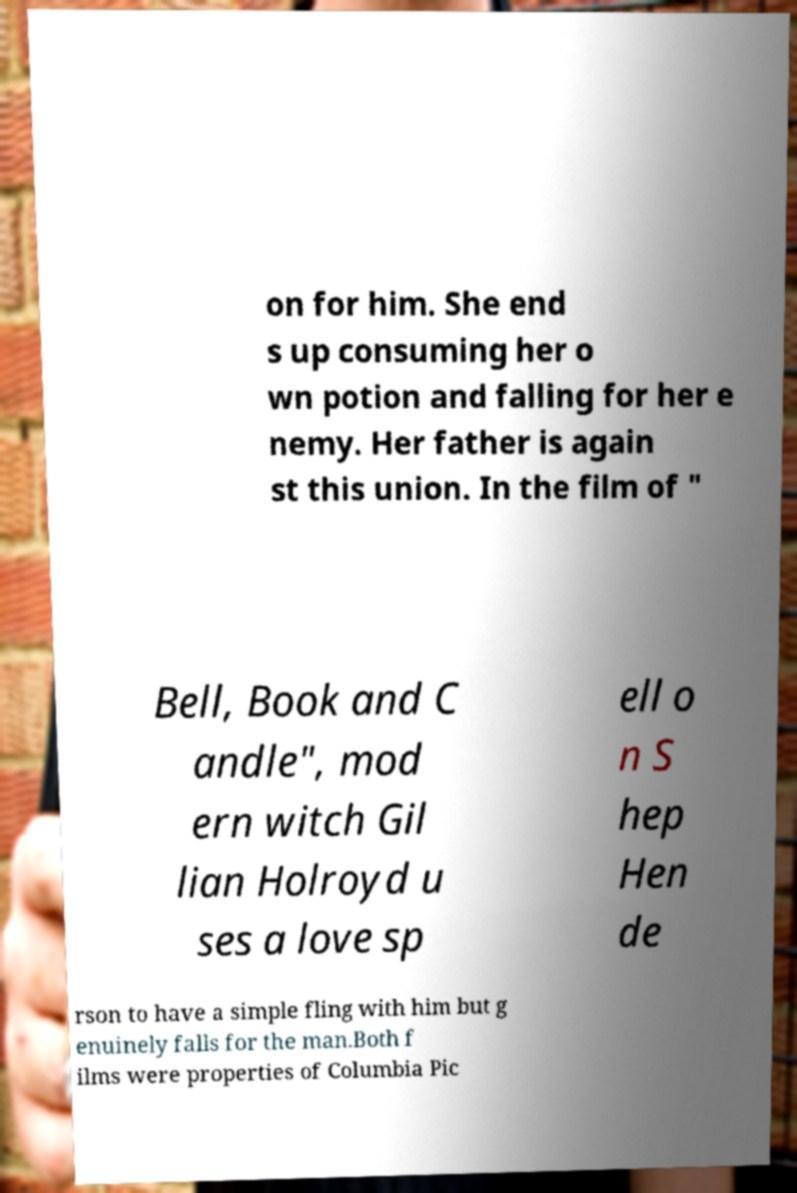Please read and relay the text visible in this image. What does it say? on for him. She end s up consuming her o wn potion and falling for her e nemy. Her father is again st this union. In the film of " Bell, Book and C andle", mod ern witch Gil lian Holroyd u ses a love sp ell o n S hep Hen de rson to have a simple fling with him but g enuinely falls for the man.Both f ilms were properties of Columbia Pic 